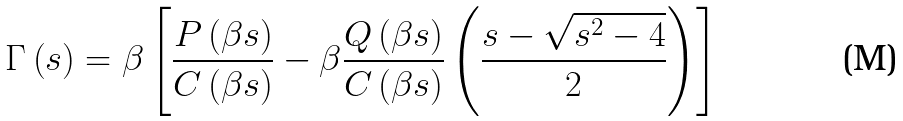<formula> <loc_0><loc_0><loc_500><loc_500>\Gamma \left ( s \right ) = \beta \left [ \frac { P \left ( \beta s \right ) } { C \left ( \beta s \right ) } - \beta \frac { Q \left ( \beta s \right ) } { C \left ( \beta s \right ) } \left ( \frac { s - \sqrt { s ^ { 2 } - 4 } } 2 \right ) \right ]</formula> 